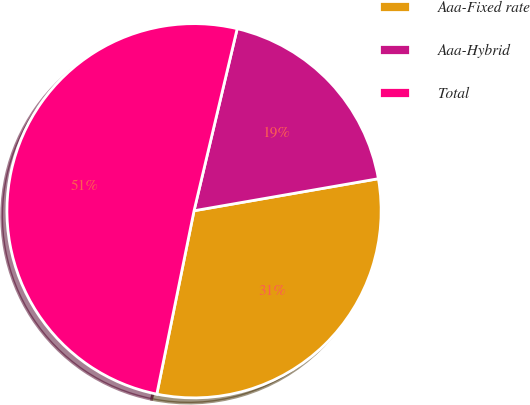Convert chart. <chart><loc_0><loc_0><loc_500><loc_500><pie_chart><fcel>Aaa-Fixed rate<fcel>Aaa-Hybrid<fcel>Total<nl><fcel>30.93%<fcel>18.56%<fcel>50.52%<nl></chart> 